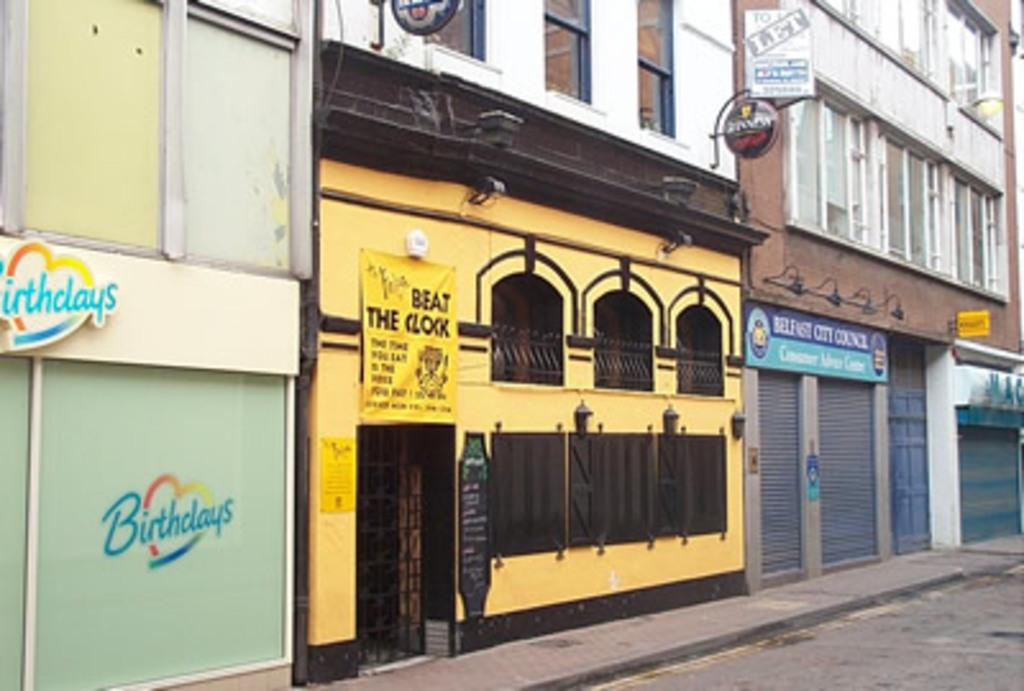What type of structures can be seen in the image? There are buildings in the image. What features do the buildings have? The buildings have windows and shutters. What other objects are present in the image? There are boards and lights in the image. What type of smell can be detected from the buildings in the image? There is no information about smells in the image, as it only provides visual details. 